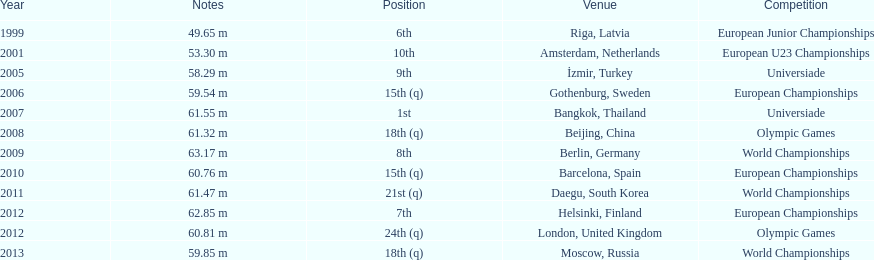Which year held the most competitions? 2012. Parse the full table. {'header': ['Year', 'Notes', 'Position', 'Venue', 'Competition'], 'rows': [['1999', '49.65 m', '6th', 'Riga, Latvia', 'European Junior Championships'], ['2001', '53.30 m', '10th', 'Amsterdam, Netherlands', 'European U23 Championships'], ['2005', '58.29 m', '9th', 'İzmir, Turkey', 'Universiade'], ['2006', '59.54 m', '15th (q)', 'Gothenburg, Sweden', 'European Championships'], ['2007', '61.55 m', '1st', 'Bangkok, Thailand', 'Universiade'], ['2008', '61.32 m', '18th (q)', 'Beijing, China', 'Olympic Games'], ['2009', '63.17 m', '8th', 'Berlin, Germany', 'World Championships'], ['2010', '60.76 m', '15th (q)', 'Barcelona, Spain', 'European Championships'], ['2011', '61.47 m', '21st (q)', 'Daegu, South Korea', 'World Championships'], ['2012', '62.85 m', '7th', 'Helsinki, Finland', 'European Championships'], ['2012', '60.81 m', '24th (q)', 'London, United Kingdom', 'Olympic Games'], ['2013', '59.85 m', '18th (q)', 'Moscow, Russia', 'World Championships']]} 